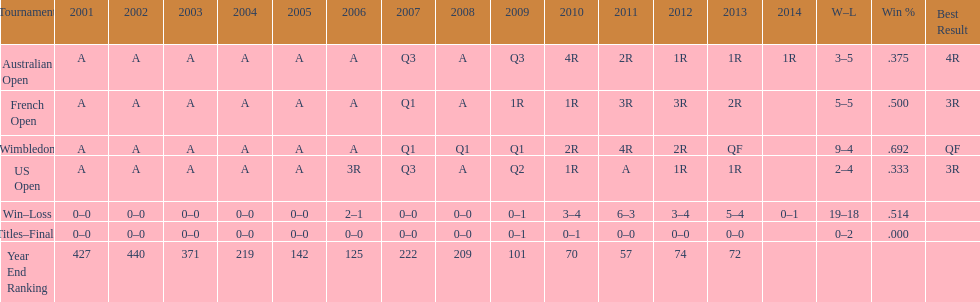What was the total number of matches played from 2001 to 2014? 37. 